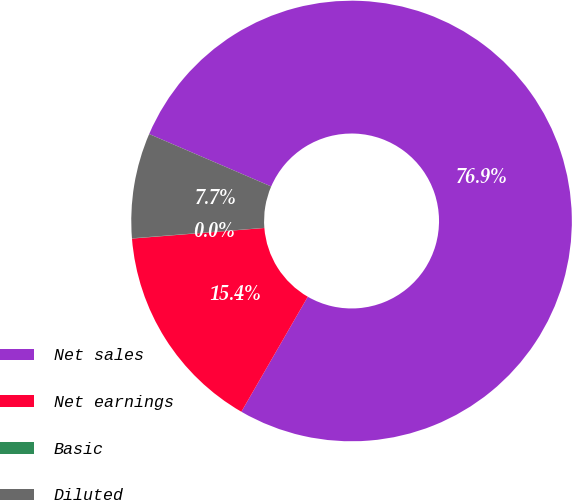<chart> <loc_0><loc_0><loc_500><loc_500><pie_chart><fcel>Net sales<fcel>Net earnings<fcel>Basic<fcel>Diluted<nl><fcel>76.88%<fcel>15.39%<fcel>0.02%<fcel>7.71%<nl></chart> 